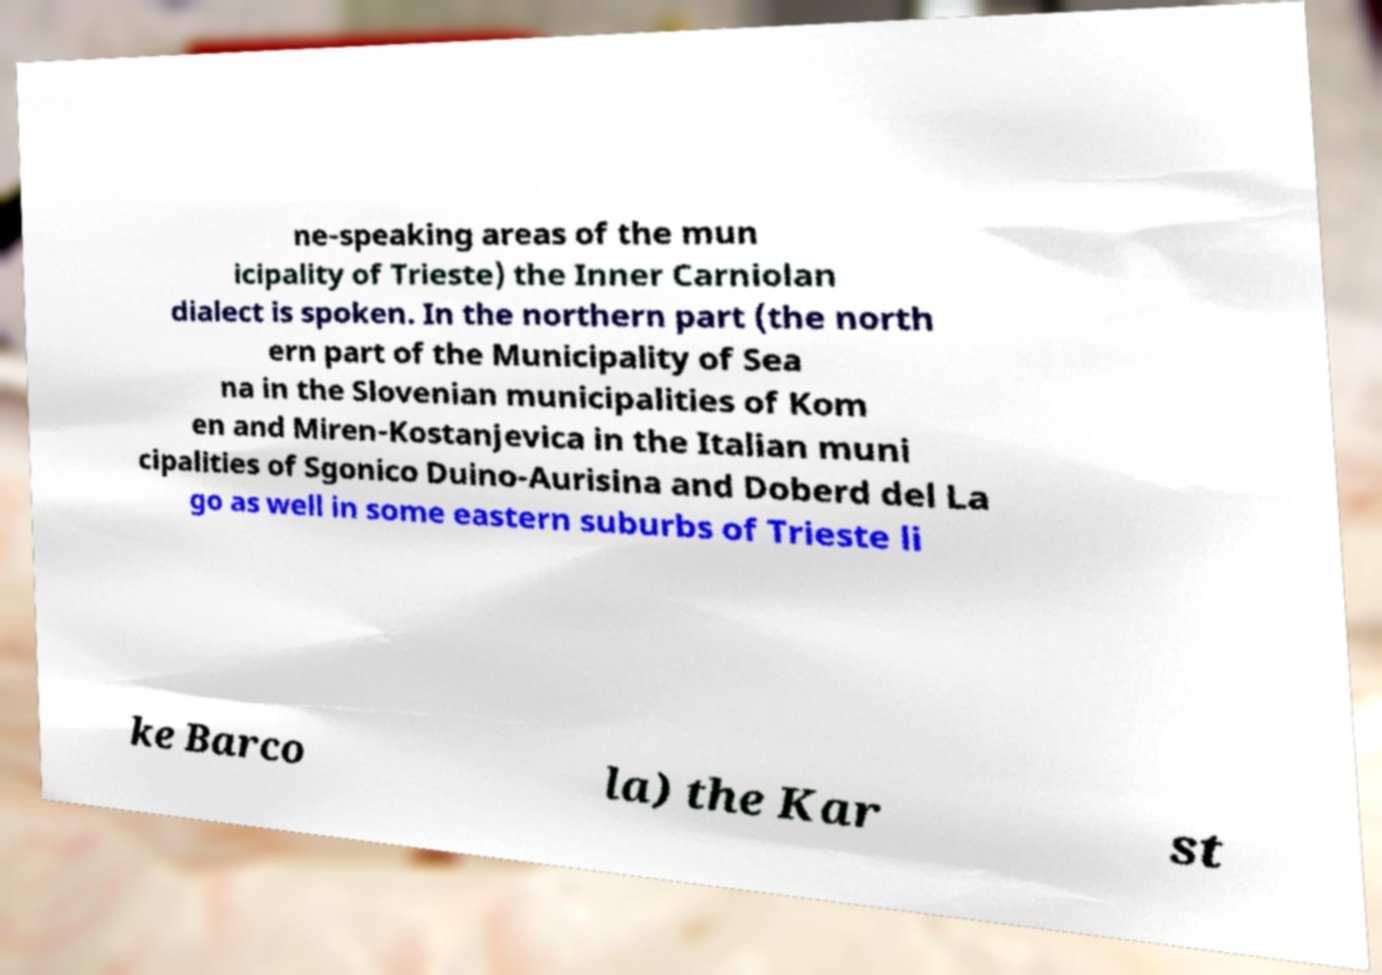Please read and relay the text visible in this image. What does it say? ne-speaking areas of the mun icipality of Trieste) the Inner Carniolan dialect is spoken. In the northern part (the north ern part of the Municipality of Sea na in the Slovenian municipalities of Kom en and Miren-Kostanjevica in the Italian muni cipalities of Sgonico Duino-Aurisina and Doberd del La go as well in some eastern suburbs of Trieste li ke Barco la) the Kar st 